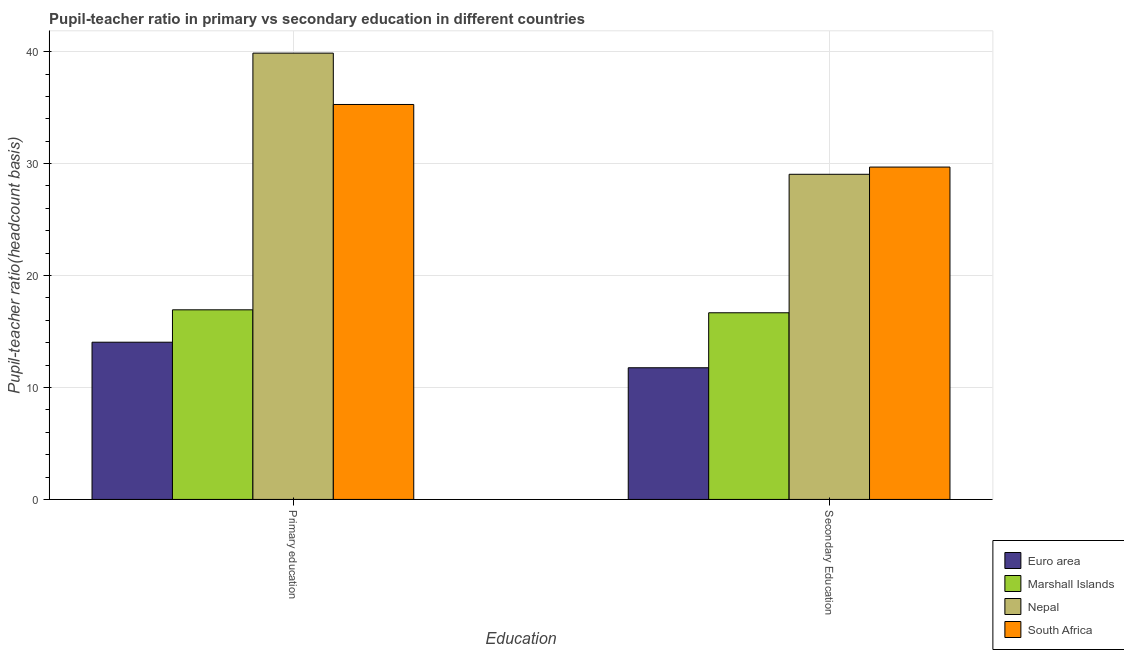Are the number of bars on each tick of the X-axis equal?
Provide a succinct answer. Yes. What is the pupil-teacher ratio in primary education in Marshall Islands?
Your answer should be very brief. 16.94. Across all countries, what is the maximum pupil teacher ratio on secondary education?
Offer a terse response. 29.69. Across all countries, what is the minimum pupil-teacher ratio in primary education?
Your answer should be compact. 14.04. In which country was the pupil teacher ratio on secondary education maximum?
Offer a terse response. South Africa. In which country was the pupil-teacher ratio in primary education minimum?
Your response must be concise. Euro area. What is the total pupil teacher ratio on secondary education in the graph?
Ensure brevity in your answer.  87.17. What is the difference between the pupil-teacher ratio in primary education in Euro area and that in Nepal?
Provide a short and direct response. -25.82. What is the difference between the pupil-teacher ratio in primary education in Euro area and the pupil teacher ratio on secondary education in Nepal?
Give a very brief answer. -15. What is the average pupil teacher ratio on secondary education per country?
Provide a short and direct response. 21.79. What is the difference between the pupil-teacher ratio in primary education and pupil teacher ratio on secondary education in Euro area?
Keep it short and to the point. 2.28. In how many countries, is the pupil-teacher ratio in primary education greater than 32 ?
Provide a succinct answer. 2. What is the ratio of the pupil-teacher ratio in primary education in South Africa to that in Nepal?
Give a very brief answer. 0.88. Is the pupil-teacher ratio in primary education in South Africa less than that in Marshall Islands?
Your answer should be very brief. No. In how many countries, is the pupil teacher ratio on secondary education greater than the average pupil teacher ratio on secondary education taken over all countries?
Provide a succinct answer. 2. What does the 3rd bar from the left in Primary education represents?
Give a very brief answer. Nepal. What does the 3rd bar from the right in Primary education represents?
Make the answer very short. Marshall Islands. Does the graph contain any zero values?
Your answer should be compact. No. Does the graph contain grids?
Ensure brevity in your answer.  Yes. How many legend labels are there?
Give a very brief answer. 4. How are the legend labels stacked?
Keep it short and to the point. Vertical. What is the title of the graph?
Keep it short and to the point. Pupil-teacher ratio in primary vs secondary education in different countries. What is the label or title of the X-axis?
Ensure brevity in your answer.  Education. What is the label or title of the Y-axis?
Your answer should be compact. Pupil-teacher ratio(headcount basis). What is the Pupil-teacher ratio(headcount basis) in Euro area in Primary education?
Provide a succinct answer. 14.04. What is the Pupil-teacher ratio(headcount basis) of Marshall Islands in Primary education?
Provide a short and direct response. 16.94. What is the Pupil-teacher ratio(headcount basis) of Nepal in Primary education?
Your response must be concise. 39.87. What is the Pupil-teacher ratio(headcount basis) of South Africa in Primary education?
Offer a terse response. 35.28. What is the Pupil-teacher ratio(headcount basis) of Euro area in Secondary Education?
Provide a short and direct response. 11.76. What is the Pupil-teacher ratio(headcount basis) in Marshall Islands in Secondary Education?
Your answer should be compact. 16.67. What is the Pupil-teacher ratio(headcount basis) of Nepal in Secondary Education?
Your answer should be very brief. 29.05. What is the Pupil-teacher ratio(headcount basis) in South Africa in Secondary Education?
Offer a very short reply. 29.69. Across all Education, what is the maximum Pupil-teacher ratio(headcount basis) in Euro area?
Keep it short and to the point. 14.04. Across all Education, what is the maximum Pupil-teacher ratio(headcount basis) of Marshall Islands?
Make the answer very short. 16.94. Across all Education, what is the maximum Pupil-teacher ratio(headcount basis) in Nepal?
Ensure brevity in your answer.  39.87. Across all Education, what is the maximum Pupil-teacher ratio(headcount basis) of South Africa?
Your answer should be very brief. 35.28. Across all Education, what is the minimum Pupil-teacher ratio(headcount basis) of Euro area?
Provide a succinct answer. 11.76. Across all Education, what is the minimum Pupil-teacher ratio(headcount basis) in Marshall Islands?
Offer a terse response. 16.67. Across all Education, what is the minimum Pupil-teacher ratio(headcount basis) in Nepal?
Give a very brief answer. 29.05. Across all Education, what is the minimum Pupil-teacher ratio(headcount basis) in South Africa?
Provide a succinct answer. 29.69. What is the total Pupil-teacher ratio(headcount basis) of Euro area in the graph?
Provide a short and direct response. 25.81. What is the total Pupil-teacher ratio(headcount basis) in Marshall Islands in the graph?
Give a very brief answer. 33.61. What is the total Pupil-teacher ratio(headcount basis) in Nepal in the graph?
Your answer should be very brief. 68.91. What is the total Pupil-teacher ratio(headcount basis) of South Africa in the graph?
Provide a short and direct response. 64.97. What is the difference between the Pupil-teacher ratio(headcount basis) in Euro area in Primary education and that in Secondary Education?
Offer a very short reply. 2.28. What is the difference between the Pupil-teacher ratio(headcount basis) in Marshall Islands in Primary education and that in Secondary Education?
Your answer should be compact. 0.26. What is the difference between the Pupil-teacher ratio(headcount basis) of Nepal in Primary education and that in Secondary Education?
Your answer should be very brief. 10.82. What is the difference between the Pupil-teacher ratio(headcount basis) in South Africa in Primary education and that in Secondary Education?
Your answer should be very brief. 5.59. What is the difference between the Pupil-teacher ratio(headcount basis) in Euro area in Primary education and the Pupil-teacher ratio(headcount basis) in Marshall Islands in Secondary Education?
Offer a terse response. -2.63. What is the difference between the Pupil-teacher ratio(headcount basis) of Euro area in Primary education and the Pupil-teacher ratio(headcount basis) of Nepal in Secondary Education?
Your answer should be compact. -15. What is the difference between the Pupil-teacher ratio(headcount basis) in Euro area in Primary education and the Pupil-teacher ratio(headcount basis) in South Africa in Secondary Education?
Offer a terse response. -15.65. What is the difference between the Pupil-teacher ratio(headcount basis) in Marshall Islands in Primary education and the Pupil-teacher ratio(headcount basis) in Nepal in Secondary Education?
Offer a very short reply. -12.11. What is the difference between the Pupil-teacher ratio(headcount basis) in Marshall Islands in Primary education and the Pupil-teacher ratio(headcount basis) in South Africa in Secondary Education?
Provide a succinct answer. -12.75. What is the difference between the Pupil-teacher ratio(headcount basis) in Nepal in Primary education and the Pupil-teacher ratio(headcount basis) in South Africa in Secondary Education?
Provide a succinct answer. 10.18. What is the average Pupil-teacher ratio(headcount basis) in Euro area per Education?
Provide a short and direct response. 12.9. What is the average Pupil-teacher ratio(headcount basis) of Marshall Islands per Education?
Offer a very short reply. 16.81. What is the average Pupil-teacher ratio(headcount basis) of Nepal per Education?
Ensure brevity in your answer.  34.46. What is the average Pupil-teacher ratio(headcount basis) in South Africa per Education?
Make the answer very short. 32.49. What is the difference between the Pupil-teacher ratio(headcount basis) of Euro area and Pupil-teacher ratio(headcount basis) of Marshall Islands in Primary education?
Offer a terse response. -2.89. What is the difference between the Pupil-teacher ratio(headcount basis) in Euro area and Pupil-teacher ratio(headcount basis) in Nepal in Primary education?
Offer a terse response. -25.82. What is the difference between the Pupil-teacher ratio(headcount basis) in Euro area and Pupil-teacher ratio(headcount basis) in South Africa in Primary education?
Keep it short and to the point. -21.24. What is the difference between the Pupil-teacher ratio(headcount basis) in Marshall Islands and Pupil-teacher ratio(headcount basis) in Nepal in Primary education?
Your response must be concise. -22.93. What is the difference between the Pupil-teacher ratio(headcount basis) in Marshall Islands and Pupil-teacher ratio(headcount basis) in South Africa in Primary education?
Your answer should be very brief. -18.34. What is the difference between the Pupil-teacher ratio(headcount basis) of Nepal and Pupil-teacher ratio(headcount basis) of South Africa in Primary education?
Make the answer very short. 4.59. What is the difference between the Pupil-teacher ratio(headcount basis) in Euro area and Pupil-teacher ratio(headcount basis) in Marshall Islands in Secondary Education?
Your answer should be very brief. -4.91. What is the difference between the Pupil-teacher ratio(headcount basis) of Euro area and Pupil-teacher ratio(headcount basis) of Nepal in Secondary Education?
Provide a short and direct response. -17.28. What is the difference between the Pupil-teacher ratio(headcount basis) of Euro area and Pupil-teacher ratio(headcount basis) of South Africa in Secondary Education?
Provide a succinct answer. -17.93. What is the difference between the Pupil-teacher ratio(headcount basis) of Marshall Islands and Pupil-teacher ratio(headcount basis) of Nepal in Secondary Education?
Provide a short and direct response. -12.37. What is the difference between the Pupil-teacher ratio(headcount basis) of Marshall Islands and Pupil-teacher ratio(headcount basis) of South Africa in Secondary Education?
Provide a short and direct response. -13.02. What is the difference between the Pupil-teacher ratio(headcount basis) in Nepal and Pupil-teacher ratio(headcount basis) in South Africa in Secondary Education?
Ensure brevity in your answer.  -0.64. What is the ratio of the Pupil-teacher ratio(headcount basis) in Euro area in Primary education to that in Secondary Education?
Provide a succinct answer. 1.19. What is the ratio of the Pupil-teacher ratio(headcount basis) in Marshall Islands in Primary education to that in Secondary Education?
Provide a short and direct response. 1.02. What is the ratio of the Pupil-teacher ratio(headcount basis) of Nepal in Primary education to that in Secondary Education?
Your response must be concise. 1.37. What is the ratio of the Pupil-teacher ratio(headcount basis) in South Africa in Primary education to that in Secondary Education?
Your answer should be very brief. 1.19. What is the difference between the highest and the second highest Pupil-teacher ratio(headcount basis) in Euro area?
Keep it short and to the point. 2.28. What is the difference between the highest and the second highest Pupil-teacher ratio(headcount basis) of Marshall Islands?
Provide a short and direct response. 0.26. What is the difference between the highest and the second highest Pupil-teacher ratio(headcount basis) of Nepal?
Your response must be concise. 10.82. What is the difference between the highest and the second highest Pupil-teacher ratio(headcount basis) of South Africa?
Provide a short and direct response. 5.59. What is the difference between the highest and the lowest Pupil-teacher ratio(headcount basis) in Euro area?
Keep it short and to the point. 2.28. What is the difference between the highest and the lowest Pupil-teacher ratio(headcount basis) in Marshall Islands?
Provide a short and direct response. 0.26. What is the difference between the highest and the lowest Pupil-teacher ratio(headcount basis) in Nepal?
Provide a short and direct response. 10.82. What is the difference between the highest and the lowest Pupil-teacher ratio(headcount basis) in South Africa?
Offer a terse response. 5.59. 